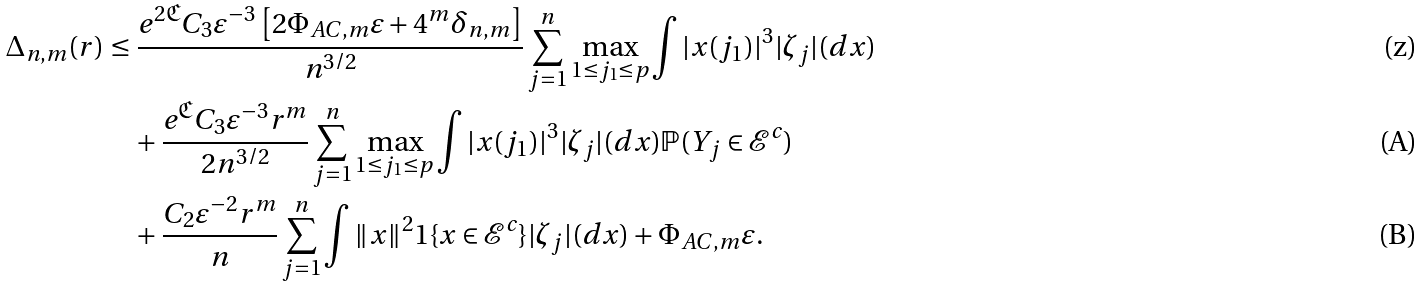<formula> <loc_0><loc_0><loc_500><loc_500>\Delta _ { n , m } ( r ) & \leq \frac { e ^ { 2 \mathfrak { C } } C _ { 3 } \varepsilon ^ { - 3 } \left [ { 2 \Phi _ { A C , m } \varepsilon } + { 4 ^ { m } \delta _ { n , m } } \right ] } { n ^ { 3 / 2 } } \sum _ { j = 1 } ^ { n } \max _ { 1 \leq j _ { 1 } \leq p } \int | x ( j _ { 1 } ) | ^ { 3 } | \zeta _ { j } | ( d x ) \\ & \quad + \frac { e ^ { \mathfrak { C } } C _ { 3 } \varepsilon ^ { - 3 } r ^ { m } } { 2 n ^ { 3 / 2 } } \sum _ { j = 1 } ^ { n } \max _ { 1 \leq j _ { 1 } \leq p } \int | x ( j _ { 1 } ) | ^ { 3 } | \zeta _ { j } | ( d x ) \mathbb { P } ( Y _ { j } \in \mathcal { E } ^ { c } ) \\ & \quad + \frac { C _ { 2 } \varepsilon ^ { - 2 } r ^ { m } } { n } \sum _ { j = 1 } ^ { n } \int \| x \| ^ { 2 } \mathbb { m } { 1 } \{ x \in \mathcal { E } ^ { c } \} | \zeta _ { j } | ( d x ) + \Phi _ { A C , m } \varepsilon .</formula> 